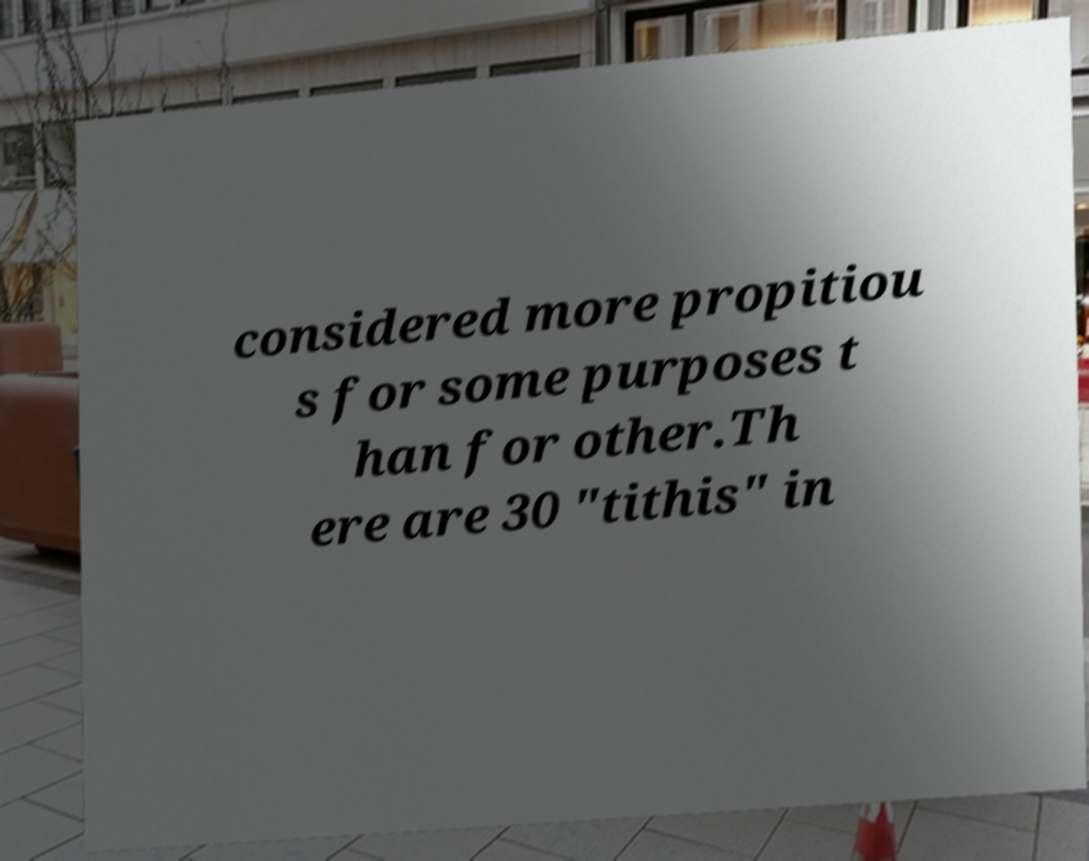Can you accurately transcribe the text from the provided image for me? considered more propitiou s for some purposes t han for other.Th ere are 30 "tithis" in 